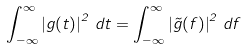<formula> <loc_0><loc_0><loc_500><loc_500>\int _ { - \infty } ^ { \infty } \left | g ( t ) \right | ^ { 2 } \, d t = \int _ { - \infty } ^ { \infty } \left | \tilde { g } ( f ) \right | ^ { 2 } \, d f</formula> 